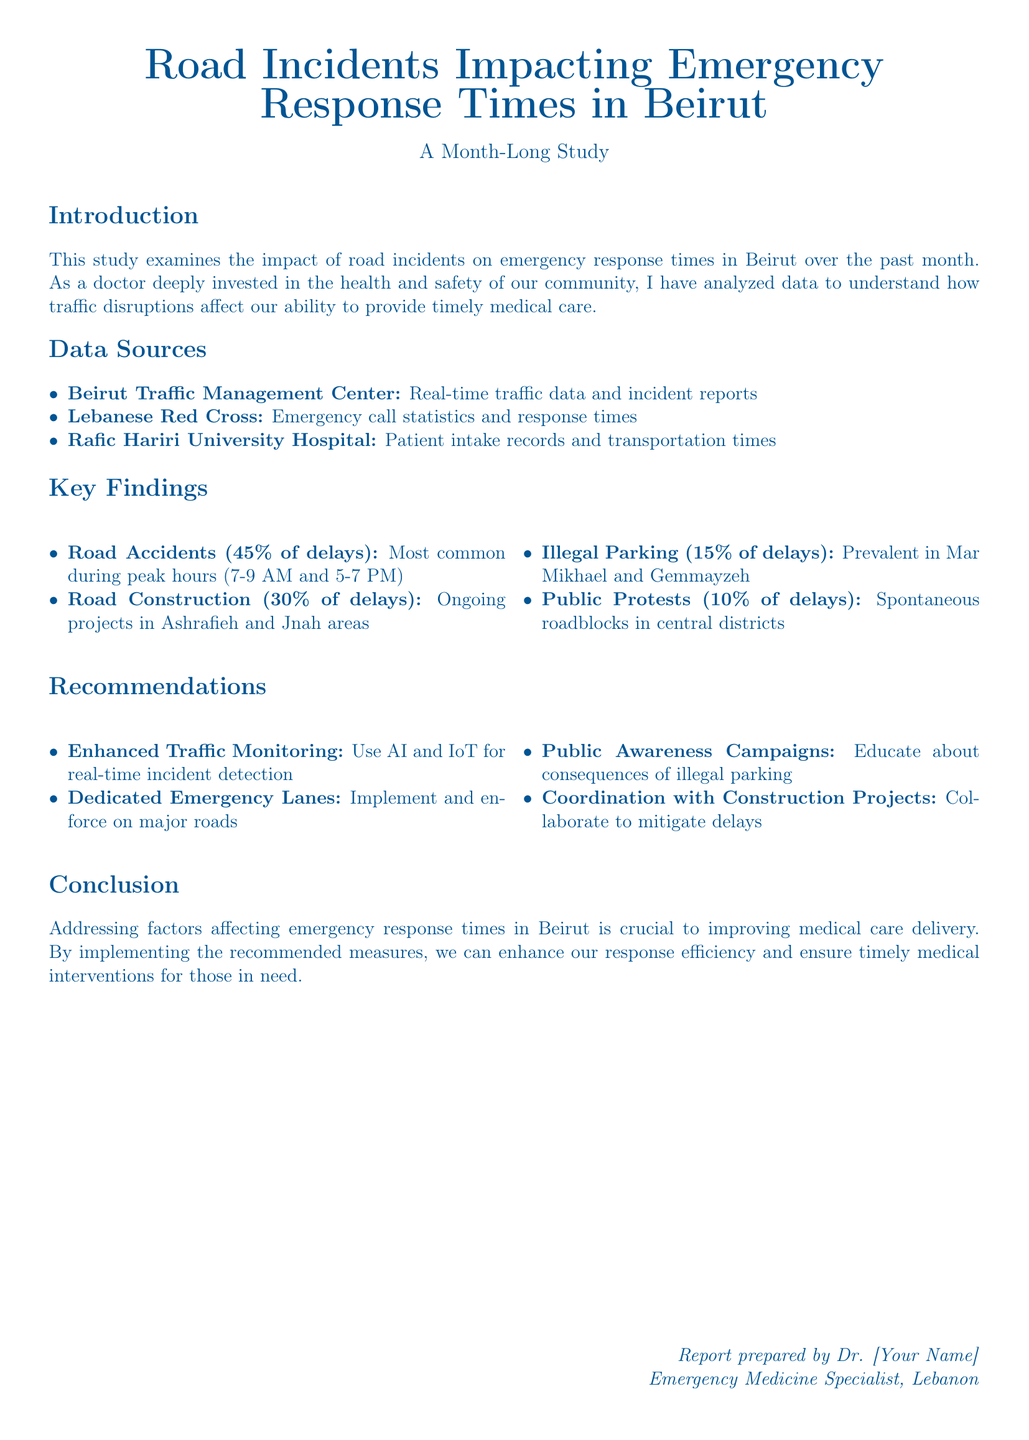what percentage of delays is caused by road accidents? The document states that road accidents account for 45% of the delays.
Answer: 45% where does ongoing road construction impact delays? The report mentions ongoing projects in the Ashrafieh and Jnah areas.
Answer: Ashrafieh and Jnah what is the percentage of delays attributed to illegal parking? The document specifies that illegal parking contributes to 15% of the delays.
Answer: 15% which organization provided emergency call statistics? The Lebanese Red Cross provided the emergency call statistics and response times.
Answer: Lebanese Red Cross what is one of the key recommendations related to traffic monitoring? The report recommends using AI and IoT for real-time incident detection.
Answer: Enhanced Traffic Monitoring how many percent of delays are caused by public protests? The report indicates that public protests contribute to 10% of the delays.
Answer: 10% what time periods are the most common for road accidents? The report specifies that peak hours for road accidents are 7-9 AM and 5-7 PM.
Answer: 7-9 AM and 5-7 PM what is a suggested measure to reduce illegal parking? The document recommends public awareness campaigns to educate about illegal parking consequences.
Answer: Public Awareness Campaigns who prepared the report? The report is prepared by a doctor, whose name is represented as [Your Name].
Answer: Dr. [Your Name] 